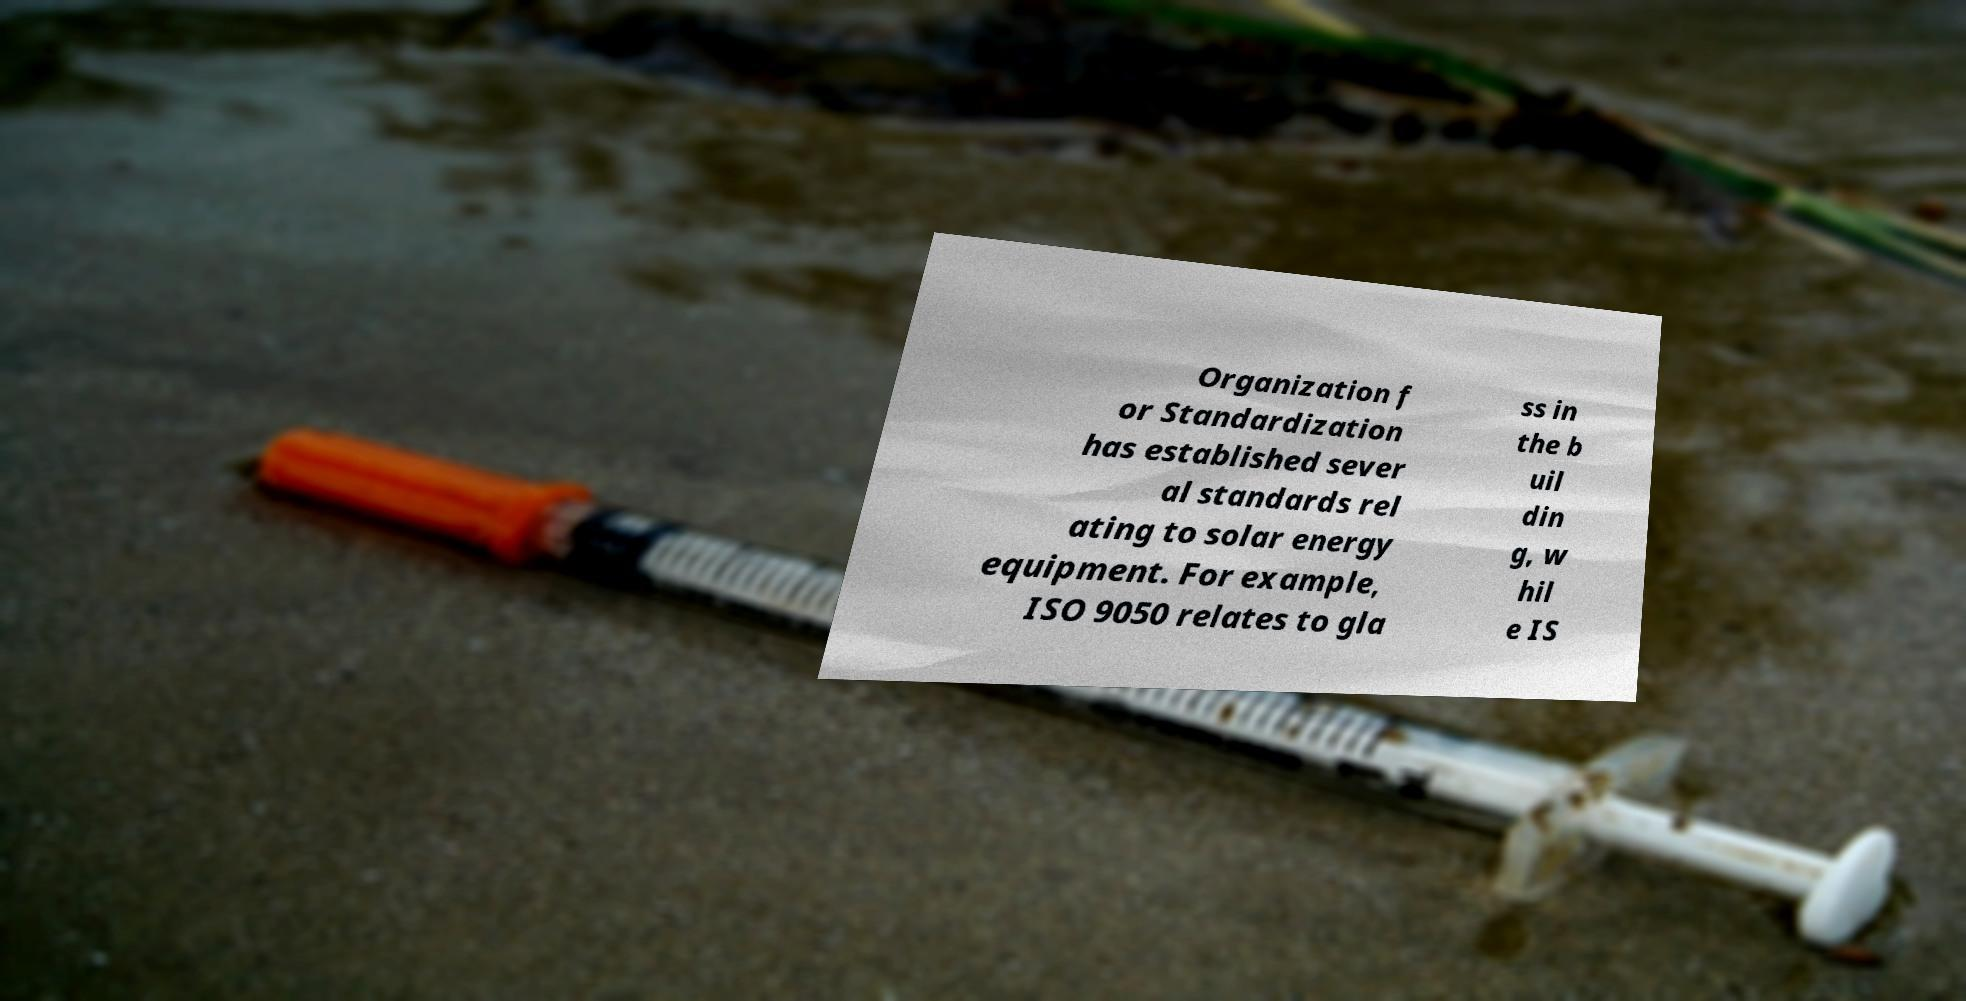Can you accurately transcribe the text from the provided image for me? Organization f or Standardization has established sever al standards rel ating to solar energy equipment. For example, ISO 9050 relates to gla ss in the b uil din g, w hil e IS 